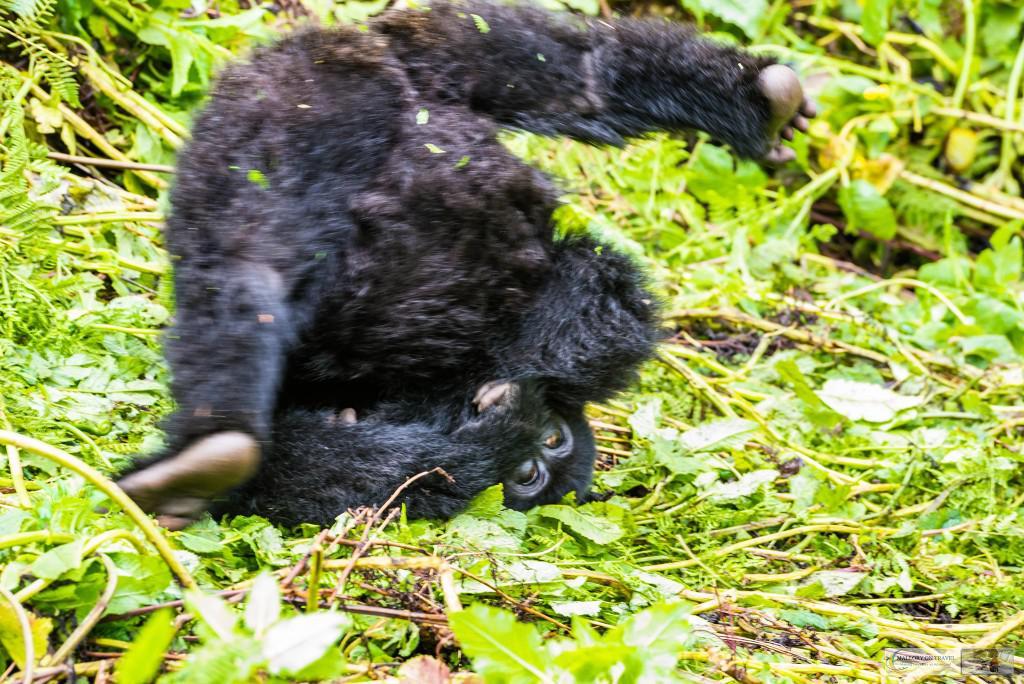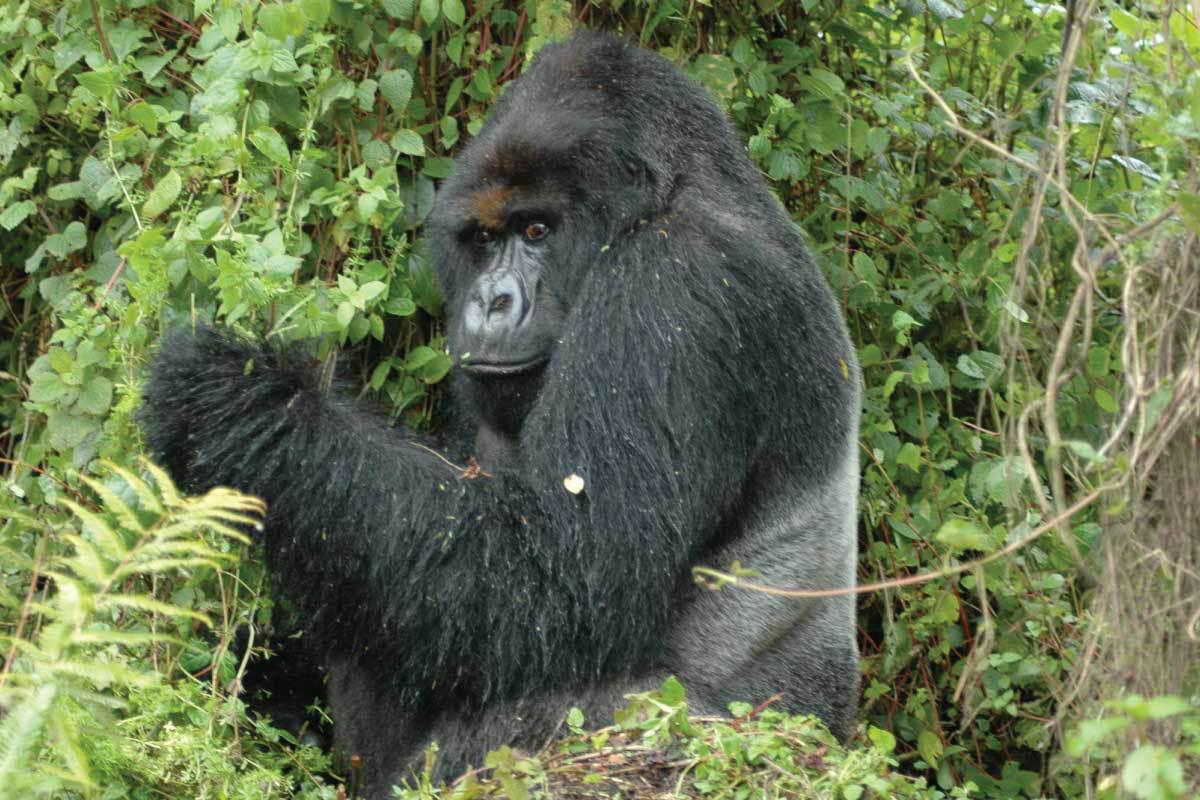The first image is the image on the left, the second image is the image on the right. Considering the images on both sides, is "A single primate is in the grass in each of the images." valid? Answer yes or no. Yes. The first image is the image on the left, the second image is the image on the right. Given the left and right images, does the statement "The right image features an adult gorilla peering leftward with a closed mouth." hold true? Answer yes or no. Yes. 